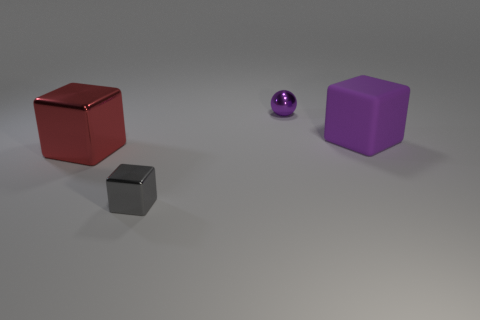How many objects are there, and can you describe their shapes? There are three objects in the image. From left to right, there's a red cube, a small grey metallic cube, and a large purple cube. The two cubes have equal sides and sharp edges, while the small object has a smooth, rounded shape indicative of a sphere. 